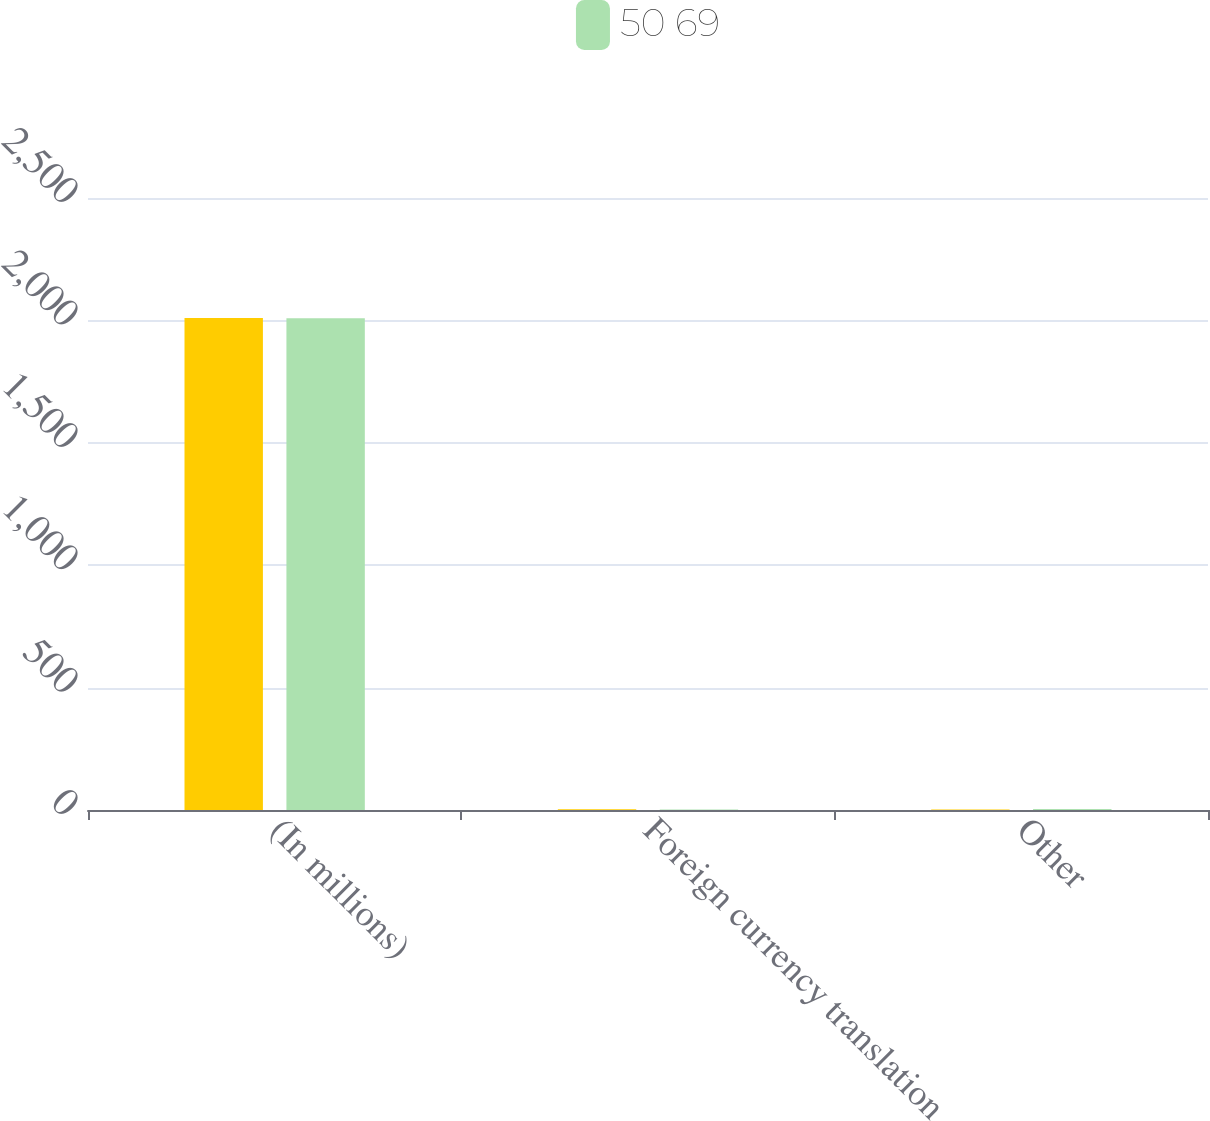<chart> <loc_0><loc_0><loc_500><loc_500><stacked_bar_chart><ecel><fcel>(In millions)<fcel>Foreign currency translation<fcel>Other<nl><fcel>nan<fcel>2010<fcel>3<fcel>2<nl><fcel>50 69<fcel>2009<fcel>2<fcel>4<nl></chart> 